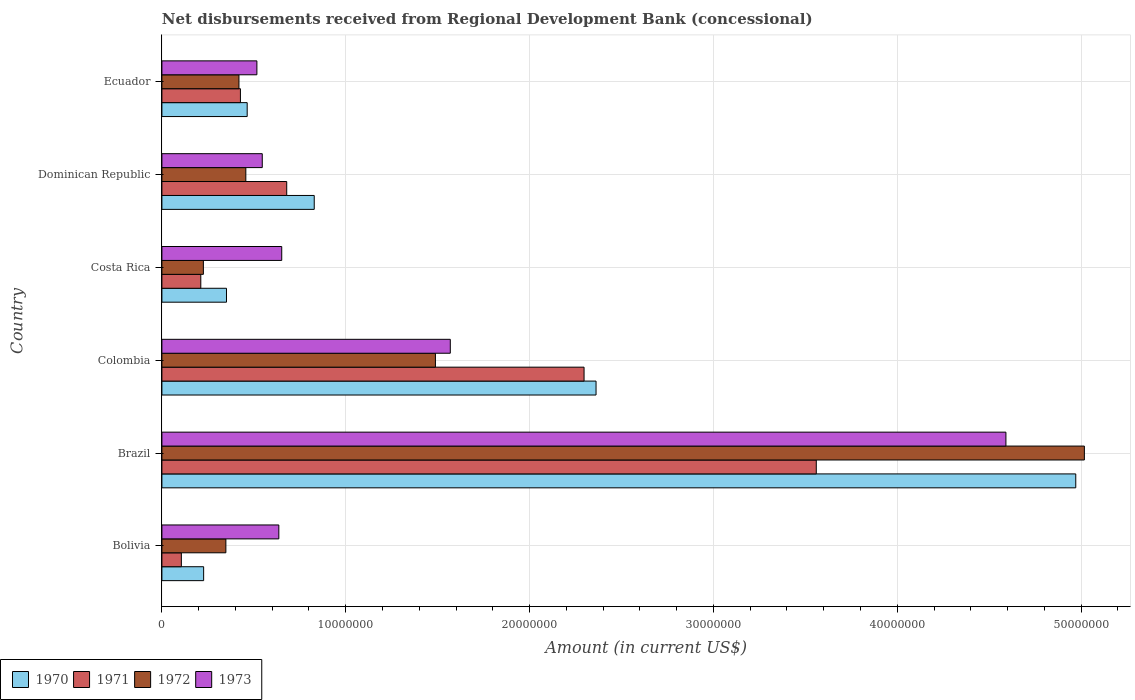Are the number of bars per tick equal to the number of legend labels?
Provide a short and direct response. Yes. How many bars are there on the 4th tick from the top?
Your answer should be compact. 4. How many bars are there on the 5th tick from the bottom?
Your answer should be compact. 4. What is the label of the 2nd group of bars from the top?
Your answer should be compact. Dominican Republic. In how many cases, is the number of bars for a given country not equal to the number of legend labels?
Your answer should be compact. 0. What is the amount of disbursements received from Regional Development Bank in 1971 in Ecuador?
Make the answer very short. 4.27e+06. Across all countries, what is the maximum amount of disbursements received from Regional Development Bank in 1973?
Your response must be concise. 4.59e+07. Across all countries, what is the minimum amount of disbursements received from Regional Development Bank in 1970?
Ensure brevity in your answer.  2.27e+06. In which country was the amount of disbursements received from Regional Development Bank in 1970 maximum?
Provide a succinct answer. Brazil. What is the total amount of disbursements received from Regional Development Bank in 1971 in the graph?
Make the answer very short. 7.28e+07. What is the difference between the amount of disbursements received from Regional Development Bank in 1972 in Colombia and that in Ecuador?
Your answer should be compact. 1.07e+07. What is the difference between the amount of disbursements received from Regional Development Bank in 1972 in Colombia and the amount of disbursements received from Regional Development Bank in 1971 in Brazil?
Keep it short and to the point. -2.07e+07. What is the average amount of disbursements received from Regional Development Bank in 1972 per country?
Ensure brevity in your answer.  1.33e+07. What is the difference between the amount of disbursements received from Regional Development Bank in 1972 and amount of disbursements received from Regional Development Bank in 1973 in Brazil?
Provide a succinct answer. 4.27e+06. What is the ratio of the amount of disbursements received from Regional Development Bank in 1973 in Brazil to that in Colombia?
Make the answer very short. 2.93. Is the difference between the amount of disbursements received from Regional Development Bank in 1972 in Bolivia and Costa Rica greater than the difference between the amount of disbursements received from Regional Development Bank in 1973 in Bolivia and Costa Rica?
Give a very brief answer. Yes. What is the difference between the highest and the second highest amount of disbursements received from Regional Development Bank in 1970?
Offer a very short reply. 2.61e+07. What is the difference between the highest and the lowest amount of disbursements received from Regional Development Bank in 1970?
Your response must be concise. 4.74e+07. In how many countries, is the amount of disbursements received from Regional Development Bank in 1972 greater than the average amount of disbursements received from Regional Development Bank in 1972 taken over all countries?
Ensure brevity in your answer.  2. Is it the case that in every country, the sum of the amount of disbursements received from Regional Development Bank in 1970 and amount of disbursements received from Regional Development Bank in 1971 is greater than the sum of amount of disbursements received from Regional Development Bank in 1972 and amount of disbursements received from Regional Development Bank in 1973?
Offer a terse response. No. What does the 1st bar from the bottom in Ecuador represents?
Offer a very short reply. 1970. Is it the case that in every country, the sum of the amount of disbursements received from Regional Development Bank in 1973 and amount of disbursements received from Regional Development Bank in 1970 is greater than the amount of disbursements received from Regional Development Bank in 1971?
Ensure brevity in your answer.  Yes. How many bars are there?
Provide a succinct answer. 24. Are all the bars in the graph horizontal?
Make the answer very short. Yes. How many countries are there in the graph?
Offer a very short reply. 6. What is the difference between two consecutive major ticks on the X-axis?
Make the answer very short. 1.00e+07. Are the values on the major ticks of X-axis written in scientific E-notation?
Provide a short and direct response. No. Does the graph contain grids?
Make the answer very short. Yes. Where does the legend appear in the graph?
Give a very brief answer. Bottom left. What is the title of the graph?
Your answer should be compact. Net disbursements received from Regional Development Bank (concessional). Does "1985" appear as one of the legend labels in the graph?
Make the answer very short. No. What is the Amount (in current US$) in 1970 in Bolivia?
Your response must be concise. 2.27e+06. What is the Amount (in current US$) in 1971 in Bolivia?
Offer a very short reply. 1.06e+06. What is the Amount (in current US$) of 1972 in Bolivia?
Offer a terse response. 3.48e+06. What is the Amount (in current US$) of 1973 in Bolivia?
Provide a short and direct response. 6.36e+06. What is the Amount (in current US$) in 1970 in Brazil?
Offer a very short reply. 4.97e+07. What is the Amount (in current US$) of 1971 in Brazil?
Your answer should be compact. 3.56e+07. What is the Amount (in current US$) of 1972 in Brazil?
Your answer should be very brief. 5.02e+07. What is the Amount (in current US$) in 1973 in Brazil?
Offer a terse response. 4.59e+07. What is the Amount (in current US$) in 1970 in Colombia?
Your response must be concise. 2.36e+07. What is the Amount (in current US$) of 1971 in Colombia?
Keep it short and to the point. 2.30e+07. What is the Amount (in current US$) in 1972 in Colombia?
Your answer should be very brief. 1.49e+07. What is the Amount (in current US$) of 1973 in Colombia?
Give a very brief answer. 1.57e+07. What is the Amount (in current US$) in 1970 in Costa Rica?
Offer a terse response. 3.51e+06. What is the Amount (in current US$) in 1971 in Costa Rica?
Provide a short and direct response. 2.12e+06. What is the Amount (in current US$) in 1972 in Costa Rica?
Give a very brief answer. 2.26e+06. What is the Amount (in current US$) of 1973 in Costa Rica?
Your response must be concise. 6.52e+06. What is the Amount (in current US$) of 1970 in Dominican Republic?
Offer a very short reply. 8.29e+06. What is the Amount (in current US$) of 1971 in Dominican Republic?
Your answer should be very brief. 6.79e+06. What is the Amount (in current US$) in 1972 in Dominican Republic?
Keep it short and to the point. 4.56e+06. What is the Amount (in current US$) of 1973 in Dominican Republic?
Make the answer very short. 5.46e+06. What is the Amount (in current US$) of 1970 in Ecuador?
Ensure brevity in your answer.  4.64e+06. What is the Amount (in current US$) of 1971 in Ecuador?
Your answer should be compact. 4.27e+06. What is the Amount (in current US$) in 1972 in Ecuador?
Your response must be concise. 4.19e+06. What is the Amount (in current US$) of 1973 in Ecuador?
Give a very brief answer. 5.17e+06. Across all countries, what is the maximum Amount (in current US$) of 1970?
Keep it short and to the point. 4.97e+07. Across all countries, what is the maximum Amount (in current US$) of 1971?
Make the answer very short. 3.56e+07. Across all countries, what is the maximum Amount (in current US$) in 1972?
Ensure brevity in your answer.  5.02e+07. Across all countries, what is the maximum Amount (in current US$) of 1973?
Make the answer very short. 4.59e+07. Across all countries, what is the minimum Amount (in current US$) in 1970?
Give a very brief answer. 2.27e+06. Across all countries, what is the minimum Amount (in current US$) of 1971?
Provide a short and direct response. 1.06e+06. Across all countries, what is the minimum Amount (in current US$) of 1972?
Offer a very short reply. 2.26e+06. Across all countries, what is the minimum Amount (in current US$) in 1973?
Provide a short and direct response. 5.17e+06. What is the total Amount (in current US$) in 1970 in the graph?
Give a very brief answer. 9.20e+07. What is the total Amount (in current US$) of 1971 in the graph?
Provide a short and direct response. 7.28e+07. What is the total Amount (in current US$) of 1972 in the graph?
Your answer should be very brief. 7.95e+07. What is the total Amount (in current US$) in 1973 in the graph?
Make the answer very short. 8.51e+07. What is the difference between the Amount (in current US$) in 1970 in Bolivia and that in Brazil?
Make the answer very short. -4.74e+07. What is the difference between the Amount (in current US$) of 1971 in Bolivia and that in Brazil?
Offer a terse response. -3.45e+07. What is the difference between the Amount (in current US$) in 1972 in Bolivia and that in Brazil?
Provide a succinct answer. -4.67e+07. What is the difference between the Amount (in current US$) of 1973 in Bolivia and that in Brazil?
Ensure brevity in your answer.  -3.95e+07. What is the difference between the Amount (in current US$) of 1970 in Bolivia and that in Colombia?
Give a very brief answer. -2.13e+07. What is the difference between the Amount (in current US$) of 1971 in Bolivia and that in Colombia?
Offer a very short reply. -2.19e+07. What is the difference between the Amount (in current US$) in 1972 in Bolivia and that in Colombia?
Offer a terse response. -1.14e+07. What is the difference between the Amount (in current US$) of 1973 in Bolivia and that in Colombia?
Provide a succinct answer. -9.33e+06. What is the difference between the Amount (in current US$) of 1970 in Bolivia and that in Costa Rica?
Provide a short and direct response. -1.24e+06. What is the difference between the Amount (in current US$) of 1971 in Bolivia and that in Costa Rica?
Keep it short and to the point. -1.06e+06. What is the difference between the Amount (in current US$) of 1972 in Bolivia and that in Costa Rica?
Make the answer very short. 1.22e+06. What is the difference between the Amount (in current US$) in 1973 in Bolivia and that in Costa Rica?
Your answer should be very brief. -1.58e+05. What is the difference between the Amount (in current US$) in 1970 in Bolivia and that in Dominican Republic?
Ensure brevity in your answer.  -6.02e+06. What is the difference between the Amount (in current US$) of 1971 in Bolivia and that in Dominican Republic?
Offer a terse response. -5.73e+06. What is the difference between the Amount (in current US$) in 1972 in Bolivia and that in Dominican Republic?
Provide a short and direct response. -1.08e+06. What is the difference between the Amount (in current US$) in 1973 in Bolivia and that in Dominican Republic?
Give a very brief answer. 9.01e+05. What is the difference between the Amount (in current US$) in 1970 in Bolivia and that in Ecuador?
Your answer should be very brief. -2.37e+06. What is the difference between the Amount (in current US$) in 1971 in Bolivia and that in Ecuador?
Keep it short and to the point. -3.21e+06. What is the difference between the Amount (in current US$) of 1972 in Bolivia and that in Ecuador?
Make the answer very short. -7.11e+05. What is the difference between the Amount (in current US$) of 1973 in Bolivia and that in Ecuador?
Make the answer very short. 1.19e+06. What is the difference between the Amount (in current US$) of 1970 in Brazil and that in Colombia?
Provide a short and direct response. 2.61e+07. What is the difference between the Amount (in current US$) of 1971 in Brazil and that in Colombia?
Keep it short and to the point. 1.26e+07. What is the difference between the Amount (in current US$) in 1972 in Brazil and that in Colombia?
Make the answer very short. 3.53e+07. What is the difference between the Amount (in current US$) in 1973 in Brazil and that in Colombia?
Provide a short and direct response. 3.02e+07. What is the difference between the Amount (in current US$) in 1970 in Brazil and that in Costa Rica?
Provide a short and direct response. 4.62e+07. What is the difference between the Amount (in current US$) of 1971 in Brazil and that in Costa Rica?
Make the answer very short. 3.35e+07. What is the difference between the Amount (in current US$) of 1972 in Brazil and that in Costa Rica?
Ensure brevity in your answer.  4.79e+07. What is the difference between the Amount (in current US$) of 1973 in Brazil and that in Costa Rica?
Keep it short and to the point. 3.94e+07. What is the difference between the Amount (in current US$) of 1970 in Brazil and that in Dominican Republic?
Your response must be concise. 4.14e+07. What is the difference between the Amount (in current US$) in 1971 in Brazil and that in Dominican Republic?
Provide a succinct answer. 2.88e+07. What is the difference between the Amount (in current US$) of 1972 in Brazil and that in Dominican Republic?
Offer a very short reply. 4.56e+07. What is the difference between the Amount (in current US$) of 1973 in Brazil and that in Dominican Republic?
Offer a terse response. 4.04e+07. What is the difference between the Amount (in current US$) in 1970 in Brazil and that in Ecuador?
Provide a short and direct response. 4.51e+07. What is the difference between the Amount (in current US$) of 1971 in Brazil and that in Ecuador?
Keep it short and to the point. 3.13e+07. What is the difference between the Amount (in current US$) of 1972 in Brazil and that in Ecuador?
Ensure brevity in your answer.  4.60e+07. What is the difference between the Amount (in current US$) in 1973 in Brazil and that in Ecuador?
Ensure brevity in your answer.  4.07e+07. What is the difference between the Amount (in current US$) in 1970 in Colombia and that in Costa Rica?
Offer a very short reply. 2.01e+07. What is the difference between the Amount (in current US$) of 1971 in Colombia and that in Costa Rica?
Offer a terse response. 2.08e+07. What is the difference between the Amount (in current US$) of 1972 in Colombia and that in Costa Rica?
Ensure brevity in your answer.  1.26e+07. What is the difference between the Amount (in current US$) in 1973 in Colombia and that in Costa Rica?
Make the answer very short. 9.17e+06. What is the difference between the Amount (in current US$) in 1970 in Colombia and that in Dominican Republic?
Make the answer very short. 1.53e+07. What is the difference between the Amount (in current US$) in 1971 in Colombia and that in Dominican Republic?
Offer a terse response. 1.62e+07. What is the difference between the Amount (in current US$) in 1972 in Colombia and that in Dominican Republic?
Keep it short and to the point. 1.03e+07. What is the difference between the Amount (in current US$) in 1973 in Colombia and that in Dominican Republic?
Ensure brevity in your answer.  1.02e+07. What is the difference between the Amount (in current US$) in 1970 in Colombia and that in Ecuador?
Give a very brief answer. 1.90e+07. What is the difference between the Amount (in current US$) of 1971 in Colombia and that in Ecuador?
Your answer should be very brief. 1.87e+07. What is the difference between the Amount (in current US$) in 1972 in Colombia and that in Ecuador?
Make the answer very short. 1.07e+07. What is the difference between the Amount (in current US$) of 1973 in Colombia and that in Ecuador?
Give a very brief answer. 1.05e+07. What is the difference between the Amount (in current US$) in 1970 in Costa Rica and that in Dominican Republic?
Your answer should be compact. -4.77e+06. What is the difference between the Amount (in current US$) of 1971 in Costa Rica and that in Dominican Republic?
Ensure brevity in your answer.  -4.67e+06. What is the difference between the Amount (in current US$) in 1972 in Costa Rica and that in Dominican Republic?
Your answer should be very brief. -2.31e+06. What is the difference between the Amount (in current US$) in 1973 in Costa Rica and that in Dominican Republic?
Provide a succinct answer. 1.06e+06. What is the difference between the Amount (in current US$) in 1970 in Costa Rica and that in Ecuador?
Offer a terse response. -1.13e+06. What is the difference between the Amount (in current US$) in 1971 in Costa Rica and that in Ecuador?
Ensure brevity in your answer.  -2.16e+06. What is the difference between the Amount (in current US$) of 1972 in Costa Rica and that in Ecuador?
Your answer should be compact. -1.94e+06. What is the difference between the Amount (in current US$) of 1973 in Costa Rica and that in Ecuador?
Ensure brevity in your answer.  1.35e+06. What is the difference between the Amount (in current US$) of 1970 in Dominican Republic and that in Ecuador?
Provide a short and direct response. 3.65e+06. What is the difference between the Amount (in current US$) in 1971 in Dominican Republic and that in Ecuador?
Your answer should be compact. 2.52e+06. What is the difference between the Amount (in current US$) in 1972 in Dominican Republic and that in Ecuador?
Provide a succinct answer. 3.74e+05. What is the difference between the Amount (in current US$) of 1973 in Dominican Republic and that in Ecuador?
Your response must be concise. 2.92e+05. What is the difference between the Amount (in current US$) of 1970 in Bolivia and the Amount (in current US$) of 1971 in Brazil?
Offer a very short reply. -3.33e+07. What is the difference between the Amount (in current US$) in 1970 in Bolivia and the Amount (in current US$) in 1972 in Brazil?
Your response must be concise. -4.79e+07. What is the difference between the Amount (in current US$) in 1970 in Bolivia and the Amount (in current US$) in 1973 in Brazil?
Provide a short and direct response. -4.36e+07. What is the difference between the Amount (in current US$) of 1971 in Bolivia and the Amount (in current US$) of 1972 in Brazil?
Make the answer very short. -4.91e+07. What is the difference between the Amount (in current US$) in 1971 in Bolivia and the Amount (in current US$) in 1973 in Brazil?
Your answer should be very brief. -4.49e+07. What is the difference between the Amount (in current US$) of 1972 in Bolivia and the Amount (in current US$) of 1973 in Brazil?
Your answer should be very brief. -4.24e+07. What is the difference between the Amount (in current US$) in 1970 in Bolivia and the Amount (in current US$) in 1971 in Colombia?
Provide a short and direct response. -2.07e+07. What is the difference between the Amount (in current US$) in 1970 in Bolivia and the Amount (in current US$) in 1972 in Colombia?
Your answer should be very brief. -1.26e+07. What is the difference between the Amount (in current US$) of 1970 in Bolivia and the Amount (in current US$) of 1973 in Colombia?
Your response must be concise. -1.34e+07. What is the difference between the Amount (in current US$) in 1971 in Bolivia and the Amount (in current US$) in 1972 in Colombia?
Offer a terse response. -1.38e+07. What is the difference between the Amount (in current US$) of 1971 in Bolivia and the Amount (in current US$) of 1973 in Colombia?
Provide a short and direct response. -1.46e+07. What is the difference between the Amount (in current US$) of 1972 in Bolivia and the Amount (in current US$) of 1973 in Colombia?
Ensure brevity in your answer.  -1.22e+07. What is the difference between the Amount (in current US$) of 1970 in Bolivia and the Amount (in current US$) of 1971 in Costa Rica?
Provide a succinct answer. 1.54e+05. What is the difference between the Amount (in current US$) of 1970 in Bolivia and the Amount (in current US$) of 1972 in Costa Rica?
Provide a succinct answer. 1.40e+04. What is the difference between the Amount (in current US$) of 1970 in Bolivia and the Amount (in current US$) of 1973 in Costa Rica?
Provide a succinct answer. -4.25e+06. What is the difference between the Amount (in current US$) of 1971 in Bolivia and the Amount (in current US$) of 1972 in Costa Rica?
Your answer should be compact. -1.20e+06. What is the difference between the Amount (in current US$) in 1971 in Bolivia and the Amount (in current US$) in 1973 in Costa Rica?
Your response must be concise. -5.46e+06. What is the difference between the Amount (in current US$) in 1972 in Bolivia and the Amount (in current US$) in 1973 in Costa Rica?
Provide a short and direct response. -3.04e+06. What is the difference between the Amount (in current US$) in 1970 in Bolivia and the Amount (in current US$) in 1971 in Dominican Republic?
Make the answer very short. -4.52e+06. What is the difference between the Amount (in current US$) of 1970 in Bolivia and the Amount (in current US$) of 1972 in Dominican Republic?
Offer a very short reply. -2.30e+06. What is the difference between the Amount (in current US$) in 1970 in Bolivia and the Amount (in current US$) in 1973 in Dominican Republic?
Your answer should be very brief. -3.19e+06. What is the difference between the Amount (in current US$) of 1971 in Bolivia and the Amount (in current US$) of 1972 in Dominican Republic?
Ensure brevity in your answer.  -3.51e+06. What is the difference between the Amount (in current US$) in 1971 in Bolivia and the Amount (in current US$) in 1973 in Dominican Republic?
Offer a very short reply. -4.40e+06. What is the difference between the Amount (in current US$) of 1972 in Bolivia and the Amount (in current US$) of 1973 in Dominican Republic?
Offer a very short reply. -1.98e+06. What is the difference between the Amount (in current US$) of 1970 in Bolivia and the Amount (in current US$) of 1971 in Ecuador?
Your answer should be very brief. -2.00e+06. What is the difference between the Amount (in current US$) of 1970 in Bolivia and the Amount (in current US$) of 1972 in Ecuador?
Keep it short and to the point. -1.92e+06. What is the difference between the Amount (in current US$) of 1970 in Bolivia and the Amount (in current US$) of 1973 in Ecuador?
Provide a succinct answer. -2.90e+06. What is the difference between the Amount (in current US$) in 1971 in Bolivia and the Amount (in current US$) in 1972 in Ecuador?
Your answer should be compact. -3.13e+06. What is the difference between the Amount (in current US$) of 1971 in Bolivia and the Amount (in current US$) of 1973 in Ecuador?
Make the answer very short. -4.11e+06. What is the difference between the Amount (in current US$) of 1972 in Bolivia and the Amount (in current US$) of 1973 in Ecuador?
Give a very brief answer. -1.69e+06. What is the difference between the Amount (in current US$) of 1970 in Brazil and the Amount (in current US$) of 1971 in Colombia?
Ensure brevity in your answer.  2.67e+07. What is the difference between the Amount (in current US$) of 1970 in Brazil and the Amount (in current US$) of 1972 in Colombia?
Provide a succinct answer. 3.48e+07. What is the difference between the Amount (in current US$) in 1970 in Brazil and the Amount (in current US$) in 1973 in Colombia?
Your answer should be very brief. 3.40e+07. What is the difference between the Amount (in current US$) of 1971 in Brazil and the Amount (in current US$) of 1972 in Colombia?
Your response must be concise. 2.07e+07. What is the difference between the Amount (in current US$) in 1971 in Brazil and the Amount (in current US$) in 1973 in Colombia?
Keep it short and to the point. 1.99e+07. What is the difference between the Amount (in current US$) of 1972 in Brazil and the Amount (in current US$) of 1973 in Colombia?
Your answer should be very brief. 3.45e+07. What is the difference between the Amount (in current US$) in 1970 in Brazil and the Amount (in current US$) in 1971 in Costa Rica?
Keep it short and to the point. 4.76e+07. What is the difference between the Amount (in current US$) in 1970 in Brazil and the Amount (in current US$) in 1972 in Costa Rica?
Provide a succinct answer. 4.75e+07. What is the difference between the Amount (in current US$) of 1970 in Brazil and the Amount (in current US$) of 1973 in Costa Rica?
Provide a succinct answer. 4.32e+07. What is the difference between the Amount (in current US$) in 1971 in Brazil and the Amount (in current US$) in 1972 in Costa Rica?
Your answer should be compact. 3.33e+07. What is the difference between the Amount (in current US$) of 1971 in Brazil and the Amount (in current US$) of 1973 in Costa Rica?
Your answer should be compact. 2.91e+07. What is the difference between the Amount (in current US$) of 1972 in Brazil and the Amount (in current US$) of 1973 in Costa Rica?
Ensure brevity in your answer.  4.37e+07. What is the difference between the Amount (in current US$) of 1970 in Brazil and the Amount (in current US$) of 1971 in Dominican Republic?
Give a very brief answer. 4.29e+07. What is the difference between the Amount (in current US$) in 1970 in Brazil and the Amount (in current US$) in 1972 in Dominican Republic?
Your answer should be very brief. 4.51e+07. What is the difference between the Amount (in current US$) in 1970 in Brazil and the Amount (in current US$) in 1973 in Dominican Republic?
Give a very brief answer. 4.42e+07. What is the difference between the Amount (in current US$) in 1971 in Brazil and the Amount (in current US$) in 1972 in Dominican Republic?
Offer a terse response. 3.10e+07. What is the difference between the Amount (in current US$) of 1971 in Brazil and the Amount (in current US$) of 1973 in Dominican Republic?
Ensure brevity in your answer.  3.01e+07. What is the difference between the Amount (in current US$) in 1972 in Brazil and the Amount (in current US$) in 1973 in Dominican Republic?
Offer a terse response. 4.47e+07. What is the difference between the Amount (in current US$) of 1970 in Brazil and the Amount (in current US$) of 1971 in Ecuador?
Keep it short and to the point. 4.54e+07. What is the difference between the Amount (in current US$) in 1970 in Brazil and the Amount (in current US$) in 1972 in Ecuador?
Your response must be concise. 4.55e+07. What is the difference between the Amount (in current US$) in 1970 in Brazil and the Amount (in current US$) in 1973 in Ecuador?
Keep it short and to the point. 4.45e+07. What is the difference between the Amount (in current US$) in 1971 in Brazil and the Amount (in current US$) in 1972 in Ecuador?
Offer a terse response. 3.14e+07. What is the difference between the Amount (in current US$) in 1971 in Brazil and the Amount (in current US$) in 1973 in Ecuador?
Provide a succinct answer. 3.04e+07. What is the difference between the Amount (in current US$) in 1972 in Brazil and the Amount (in current US$) in 1973 in Ecuador?
Give a very brief answer. 4.50e+07. What is the difference between the Amount (in current US$) in 1970 in Colombia and the Amount (in current US$) in 1971 in Costa Rica?
Your response must be concise. 2.15e+07. What is the difference between the Amount (in current US$) in 1970 in Colombia and the Amount (in current US$) in 1972 in Costa Rica?
Your response must be concise. 2.14e+07. What is the difference between the Amount (in current US$) in 1970 in Colombia and the Amount (in current US$) in 1973 in Costa Rica?
Ensure brevity in your answer.  1.71e+07. What is the difference between the Amount (in current US$) of 1971 in Colombia and the Amount (in current US$) of 1972 in Costa Rica?
Your answer should be compact. 2.07e+07. What is the difference between the Amount (in current US$) of 1971 in Colombia and the Amount (in current US$) of 1973 in Costa Rica?
Keep it short and to the point. 1.64e+07. What is the difference between the Amount (in current US$) of 1972 in Colombia and the Amount (in current US$) of 1973 in Costa Rica?
Ensure brevity in your answer.  8.36e+06. What is the difference between the Amount (in current US$) of 1970 in Colombia and the Amount (in current US$) of 1971 in Dominican Republic?
Your answer should be compact. 1.68e+07. What is the difference between the Amount (in current US$) of 1970 in Colombia and the Amount (in current US$) of 1972 in Dominican Republic?
Your answer should be compact. 1.90e+07. What is the difference between the Amount (in current US$) in 1970 in Colombia and the Amount (in current US$) in 1973 in Dominican Republic?
Provide a succinct answer. 1.82e+07. What is the difference between the Amount (in current US$) of 1971 in Colombia and the Amount (in current US$) of 1972 in Dominican Republic?
Keep it short and to the point. 1.84e+07. What is the difference between the Amount (in current US$) of 1971 in Colombia and the Amount (in current US$) of 1973 in Dominican Republic?
Provide a short and direct response. 1.75e+07. What is the difference between the Amount (in current US$) of 1972 in Colombia and the Amount (in current US$) of 1973 in Dominican Republic?
Offer a very short reply. 9.42e+06. What is the difference between the Amount (in current US$) of 1970 in Colombia and the Amount (in current US$) of 1971 in Ecuador?
Offer a very short reply. 1.93e+07. What is the difference between the Amount (in current US$) in 1970 in Colombia and the Amount (in current US$) in 1972 in Ecuador?
Your answer should be very brief. 1.94e+07. What is the difference between the Amount (in current US$) of 1970 in Colombia and the Amount (in current US$) of 1973 in Ecuador?
Give a very brief answer. 1.84e+07. What is the difference between the Amount (in current US$) of 1971 in Colombia and the Amount (in current US$) of 1972 in Ecuador?
Your answer should be compact. 1.88e+07. What is the difference between the Amount (in current US$) of 1971 in Colombia and the Amount (in current US$) of 1973 in Ecuador?
Your answer should be very brief. 1.78e+07. What is the difference between the Amount (in current US$) in 1972 in Colombia and the Amount (in current US$) in 1973 in Ecuador?
Your answer should be very brief. 9.71e+06. What is the difference between the Amount (in current US$) of 1970 in Costa Rica and the Amount (in current US$) of 1971 in Dominican Republic?
Ensure brevity in your answer.  -3.28e+06. What is the difference between the Amount (in current US$) in 1970 in Costa Rica and the Amount (in current US$) in 1972 in Dominican Republic?
Keep it short and to the point. -1.05e+06. What is the difference between the Amount (in current US$) in 1970 in Costa Rica and the Amount (in current US$) in 1973 in Dominican Republic?
Keep it short and to the point. -1.95e+06. What is the difference between the Amount (in current US$) of 1971 in Costa Rica and the Amount (in current US$) of 1972 in Dominican Republic?
Keep it short and to the point. -2.45e+06. What is the difference between the Amount (in current US$) of 1971 in Costa Rica and the Amount (in current US$) of 1973 in Dominican Republic?
Offer a terse response. -3.34e+06. What is the difference between the Amount (in current US$) of 1972 in Costa Rica and the Amount (in current US$) of 1973 in Dominican Republic?
Give a very brief answer. -3.20e+06. What is the difference between the Amount (in current US$) in 1970 in Costa Rica and the Amount (in current US$) in 1971 in Ecuador?
Your response must be concise. -7.58e+05. What is the difference between the Amount (in current US$) in 1970 in Costa Rica and the Amount (in current US$) in 1972 in Ecuador?
Your response must be concise. -6.78e+05. What is the difference between the Amount (in current US$) in 1970 in Costa Rica and the Amount (in current US$) in 1973 in Ecuador?
Offer a very short reply. -1.65e+06. What is the difference between the Amount (in current US$) in 1971 in Costa Rica and the Amount (in current US$) in 1972 in Ecuador?
Your answer should be very brief. -2.08e+06. What is the difference between the Amount (in current US$) of 1971 in Costa Rica and the Amount (in current US$) of 1973 in Ecuador?
Make the answer very short. -3.05e+06. What is the difference between the Amount (in current US$) in 1972 in Costa Rica and the Amount (in current US$) in 1973 in Ecuador?
Keep it short and to the point. -2.91e+06. What is the difference between the Amount (in current US$) in 1970 in Dominican Republic and the Amount (in current US$) in 1971 in Ecuador?
Provide a short and direct response. 4.02e+06. What is the difference between the Amount (in current US$) in 1970 in Dominican Republic and the Amount (in current US$) in 1972 in Ecuador?
Offer a very short reply. 4.10e+06. What is the difference between the Amount (in current US$) of 1970 in Dominican Republic and the Amount (in current US$) of 1973 in Ecuador?
Provide a short and direct response. 3.12e+06. What is the difference between the Amount (in current US$) of 1971 in Dominican Republic and the Amount (in current US$) of 1972 in Ecuador?
Provide a short and direct response. 2.60e+06. What is the difference between the Amount (in current US$) of 1971 in Dominican Republic and the Amount (in current US$) of 1973 in Ecuador?
Give a very brief answer. 1.62e+06. What is the difference between the Amount (in current US$) in 1972 in Dominican Republic and the Amount (in current US$) in 1973 in Ecuador?
Offer a very short reply. -6.02e+05. What is the average Amount (in current US$) of 1970 per country?
Your response must be concise. 1.53e+07. What is the average Amount (in current US$) in 1971 per country?
Your answer should be very brief. 1.21e+07. What is the average Amount (in current US$) in 1972 per country?
Your answer should be compact. 1.33e+07. What is the average Amount (in current US$) in 1973 per country?
Provide a succinct answer. 1.42e+07. What is the difference between the Amount (in current US$) of 1970 and Amount (in current US$) of 1971 in Bolivia?
Your answer should be compact. 1.21e+06. What is the difference between the Amount (in current US$) of 1970 and Amount (in current US$) of 1972 in Bolivia?
Offer a very short reply. -1.21e+06. What is the difference between the Amount (in current US$) of 1970 and Amount (in current US$) of 1973 in Bolivia?
Offer a terse response. -4.09e+06. What is the difference between the Amount (in current US$) of 1971 and Amount (in current US$) of 1972 in Bolivia?
Make the answer very short. -2.42e+06. What is the difference between the Amount (in current US$) in 1971 and Amount (in current US$) in 1973 in Bolivia?
Offer a very short reply. -5.30e+06. What is the difference between the Amount (in current US$) of 1972 and Amount (in current US$) of 1973 in Bolivia?
Provide a succinct answer. -2.88e+06. What is the difference between the Amount (in current US$) in 1970 and Amount (in current US$) in 1971 in Brazil?
Your answer should be very brief. 1.41e+07. What is the difference between the Amount (in current US$) in 1970 and Amount (in current US$) in 1972 in Brazil?
Your response must be concise. -4.68e+05. What is the difference between the Amount (in current US$) in 1970 and Amount (in current US$) in 1973 in Brazil?
Give a very brief answer. 3.80e+06. What is the difference between the Amount (in current US$) of 1971 and Amount (in current US$) of 1972 in Brazil?
Ensure brevity in your answer.  -1.46e+07. What is the difference between the Amount (in current US$) in 1971 and Amount (in current US$) in 1973 in Brazil?
Your answer should be very brief. -1.03e+07. What is the difference between the Amount (in current US$) in 1972 and Amount (in current US$) in 1973 in Brazil?
Your answer should be very brief. 4.27e+06. What is the difference between the Amount (in current US$) in 1970 and Amount (in current US$) in 1971 in Colombia?
Offer a very short reply. 6.52e+05. What is the difference between the Amount (in current US$) in 1970 and Amount (in current US$) in 1972 in Colombia?
Provide a succinct answer. 8.74e+06. What is the difference between the Amount (in current US$) of 1970 and Amount (in current US$) of 1973 in Colombia?
Give a very brief answer. 7.93e+06. What is the difference between the Amount (in current US$) of 1971 and Amount (in current US$) of 1972 in Colombia?
Make the answer very short. 8.08e+06. What is the difference between the Amount (in current US$) of 1971 and Amount (in current US$) of 1973 in Colombia?
Make the answer very short. 7.28e+06. What is the difference between the Amount (in current US$) of 1972 and Amount (in current US$) of 1973 in Colombia?
Keep it short and to the point. -8.09e+05. What is the difference between the Amount (in current US$) in 1970 and Amount (in current US$) in 1971 in Costa Rica?
Keep it short and to the point. 1.40e+06. What is the difference between the Amount (in current US$) in 1970 and Amount (in current US$) in 1972 in Costa Rica?
Offer a very short reply. 1.26e+06. What is the difference between the Amount (in current US$) in 1970 and Amount (in current US$) in 1973 in Costa Rica?
Offer a terse response. -3.00e+06. What is the difference between the Amount (in current US$) in 1971 and Amount (in current US$) in 1972 in Costa Rica?
Ensure brevity in your answer.  -1.40e+05. What is the difference between the Amount (in current US$) of 1971 and Amount (in current US$) of 1973 in Costa Rica?
Provide a short and direct response. -4.40e+06. What is the difference between the Amount (in current US$) in 1972 and Amount (in current US$) in 1973 in Costa Rica?
Your answer should be very brief. -4.26e+06. What is the difference between the Amount (in current US$) of 1970 and Amount (in current US$) of 1971 in Dominican Republic?
Your answer should be compact. 1.50e+06. What is the difference between the Amount (in current US$) in 1970 and Amount (in current US$) in 1972 in Dominican Republic?
Your answer should be very brief. 3.72e+06. What is the difference between the Amount (in current US$) of 1970 and Amount (in current US$) of 1973 in Dominican Republic?
Give a very brief answer. 2.83e+06. What is the difference between the Amount (in current US$) in 1971 and Amount (in current US$) in 1972 in Dominican Republic?
Make the answer very short. 2.22e+06. What is the difference between the Amount (in current US$) of 1971 and Amount (in current US$) of 1973 in Dominican Republic?
Offer a very short reply. 1.33e+06. What is the difference between the Amount (in current US$) of 1972 and Amount (in current US$) of 1973 in Dominican Republic?
Your answer should be very brief. -8.94e+05. What is the difference between the Amount (in current US$) in 1970 and Amount (in current US$) in 1971 in Ecuador?
Make the answer very short. 3.68e+05. What is the difference between the Amount (in current US$) of 1970 and Amount (in current US$) of 1972 in Ecuador?
Offer a very short reply. 4.48e+05. What is the difference between the Amount (in current US$) in 1970 and Amount (in current US$) in 1973 in Ecuador?
Ensure brevity in your answer.  -5.28e+05. What is the difference between the Amount (in current US$) of 1971 and Amount (in current US$) of 1972 in Ecuador?
Give a very brief answer. 8.00e+04. What is the difference between the Amount (in current US$) of 1971 and Amount (in current US$) of 1973 in Ecuador?
Offer a very short reply. -8.96e+05. What is the difference between the Amount (in current US$) of 1972 and Amount (in current US$) of 1973 in Ecuador?
Keep it short and to the point. -9.76e+05. What is the ratio of the Amount (in current US$) of 1970 in Bolivia to that in Brazil?
Give a very brief answer. 0.05. What is the ratio of the Amount (in current US$) of 1971 in Bolivia to that in Brazil?
Your answer should be very brief. 0.03. What is the ratio of the Amount (in current US$) in 1972 in Bolivia to that in Brazil?
Ensure brevity in your answer.  0.07. What is the ratio of the Amount (in current US$) of 1973 in Bolivia to that in Brazil?
Give a very brief answer. 0.14. What is the ratio of the Amount (in current US$) in 1970 in Bolivia to that in Colombia?
Your answer should be very brief. 0.1. What is the ratio of the Amount (in current US$) of 1971 in Bolivia to that in Colombia?
Offer a terse response. 0.05. What is the ratio of the Amount (in current US$) of 1972 in Bolivia to that in Colombia?
Your answer should be compact. 0.23. What is the ratio of the Amount (in current US$) of 1973 in Bolivia to that in Colombia?
Give a very brief answer. 0.41. What is the ratio of the Amount (in current US$) in 1970 in Bolivia to that in Costa Rica?
Make the answer very short. 0.65. What is the ratio of the Amount (in current US$) of 1972 in Bolivia to that in Costa Rica?
Your answer should be compact. 1.54. What is the ratio of the Amount (in current US$) of 1973 in Bolivia to that in Costa Rica?
Your response must be concise. 0.98. What is the ratio of the Amount (in current US$) in 1970 in Bolivia to that in Dominican Republic?
Provide a short and direct response. 0.27. What is the ratio of the Amount (in current US$) of 1971 in Bolivia to that in Dominican Republic?
Your answer should be compact. 0.16. What is the ratio of the Amount (in current US$) in 1972 in Bolivia to that in Dominican Republic?
Your response must be concise. 0.76. What is the ratio of the Amount (in current US$) of 1973 in Bolivia to that in Dominican Republic?
Keep it short and to the point. 1.17. What is the ratio of the Amount (in current US$) in 1970 in Bolivia to that in Ecuador?
Ensure brevity in your answer.  0.49. What is the ratio of the Amount (in current US$) in 1971 in Bolivia to that in Ecuador?
Your answer should be compact. 0.25. What is the ratio of the Amount (in current US$) in 1972 in Bolivia to that in Ecuador?
Make the answer very short. 0.83. What is the ratio of the Amount (in current US$) in 1973 in Bolivia to that in Ecuador?
Your answer should be compact. 1.23. What is the ratio of the Amount (in current US$) in 1970 in Brazil to that in Colombia?
Offer a terse response. 2.1. What is the ratio of the Amount (in current US$) of 1971 in Brazil to that in Colombia?
Your response must be concise. 1.55. What is the ratio of the Amount (in current US$) of 1972 in Brazil to that in Colombia?
Keep it short and to the point. 3.37. What is the ratio of the Amount (in current US$) in 1973 in Brazil to that in Colombia?
Make the answer very short. 2.93. What is the ratio of the Amount (in current US$) of 1970 in Brazil to that in Costa Rica?
Keep it short and to the point. 14.15. What is the ratio of the Amount (in current US$) of 1971 in Brazil to that in Costa Rica?
Offer a terse response. 16.82. What is the ratio of the Amount (in current US$) in 1972 in Brazil to that in Costa Rica?
Your response must be concise. 22.24. What is the ratio of the Amount (in current US$) in 1973 in Brazil to that in Costa Rica?
Your answer should be very brief. 7.04. What is the ratio of the Amount (in current US$) in 1970 in Brazil to that in Dominican Republic?
Ensure brevity in your answer.  6. What is the ratio of the Amount (in current US$) in 1971 in Brazil to that in Dominican Republic?
Keep it short and to the point. 5.24. What is the ratio of the Amount (in current US$) of 1972 in Brazil to that in Dominican Republic?
Provide a short and direct response. 10.99. What is the ratio of the Amount (in current US$) of 1973 in Brazil to that in Dominican Republic?
Give a very brief answer. 8.41. What is the ratio of the Amount (in current US$) of 1970 in Brazil to that in Ecuador?
Your answer should be very brief. 10.72. What is the ratio of the Amount (in current US$) of 1971 in Brazil to that in Ecuador?
Provide a succinct answer. 8.33. What is the ratio of the Amount (in current US$) in 1972 in Brazil to that in Ecuador?
Your answer should be very brief. 11.97. What is the ratio of the Amount (in current US$) of 1973 in Brazil to that in Ecuador?
Offer a very short reply. 8.88. What is the ratio of the Amount (in current US$) in 1970 in Colombia to that in Costa Rica?
Provide a succinct answer. 6.72. What is the ratio of the Amount (in current US$) in 1971 in Colombia to that in Costa Rica?
Offer a very short reply. 10.85. What is the ratio of the Amount (in current US$) of 1972 in Colombia to that in Costa Rica?
Make the answer very short. 6.59. What is the ratio of the Amount (in current US$) in 1973 in Colombia to that in Costa Rica?
Make the answer very short. 2.41. What is the ratio of the Amount (in current US$) in 1970 in Colombia to that in Dominican Republic?
Offer a very short reply. 2.85. What is the ratio of the Amount (in current US$) of 1971 in Colombia to that in Dominican Republic?
Ensure brevity in your answer.  3.38. What is the ratio of the Amount (in current US$) of 1972 in Colombia to that in Dominican Republic?
Ensure brevity in your answer.  3.26. What is the ratio of the Amount (in current US$) of 1973 in Colombia to that in Dominican Republic?
Your answer should be very brief. 2.87. What is the ratio of the Amount (in current US$) in 1970 in Colombia to that in Ecuador?
Give a very brief answer. 5.09. What is the ratio of the Amount (in current US$) in 1971 in Colombia to that in Ecuador?
Keep it short and to the point. 5.38. What is the ratio of the Amount (in current US$) of 1972 in Colombia to that in Ecuador?
Provide a short and direct response. 3.55. What is the ratio of the Amount (in current US$) of 1973 in Colombia to that in Ecuador?
Ensure brevity in your answer.  3.04. What is the ratio of the Amount (in current US$) in 1970 in Costa Rica to that in Dominican Republic?
Keep it short and to the point. 0.42. What is the ratio of the Amount (in current US$) of 1971 in Costa Rica to that in Dominican Republic?
Offer a terse response. 0.31. What is the ratio of the Amount (in current US$) in 1972 in Costa Rica to that in Dominican Republic?
Offer a terse response. 0.49. What is the ratio of the Amount (in current US$) in 1973 in Costa Rica to that in Dominican Republic?
Your answer should be compact. 1.19. What is the ratio of the Amount (in current US$) of 1970 in Costa Rica to that in Ecuador?
Offer a terse response. 0.76. What is the ratio of the Amount (in current US$) of 1971 in Costa Rica to that in Ecuador?
Your answer should be compact. 0.5. What is the ratio of the Amount (in current US$) in 1972 in Costa Rica to that in Ecuador?
Your answer should be very brief. 0.54. What is the ratio of the Amount (in current US$) in 1973 in Costa Rica to that in Ecuador?
Your answer should be very brief. 1.26. What is the ratio of the Amount (in current US$) of 1970 in Dominican Republic to that in Ecuador?
Ensure brevity in your answer.  1.79. What is the ratio of the Amount (in current US$) in 1971 in Dominican Republic to that in Ecuador?
Keep it short and to the point. 1.59. What is the ratio of the Amount (in current US$) in 1972 in Dominican Republic to that in Ecuador?
Offer a terse response. 1.09. What is the ratio of the Amount (in current US$) of 1973 in Dominican Republic to that in Ecuador?
Your answer should be compact. 1.06. What is the difference between the highest and the second highest Amount (in current US$) of 1970?
Provide a succinct answer. 2.61e+07. What is the difference between the highest and the second highest Amount (in current US$) in 1971?
Your answer should be compact. 1.26e+07. What is the difference between the highest and the second highest Amount (in current US$) in 1972?
Offer a terse response. 3.53e+07. What is the difference between the highest and the second highest Amount (in current US$) in 1973?
Your answer should be compact. 3.02e+07. What is the difference between the highest and the lowest Amount (in current US$) of 1970?
Provide a succinct answer. 4.74e+07. What is the difference between the highest and the lowest Amount (in current US$) of 1971?
Your response must be concise. 3.45e+07. What is the difference between the highest and the lowest Amount (in current US$) of 1972?
Your answer should be compact. 4.79e+07. What is the difference between the highest and the lowest Amount (in current US$) of 1973?
Provide a succinct answer. 4.07e+07. 